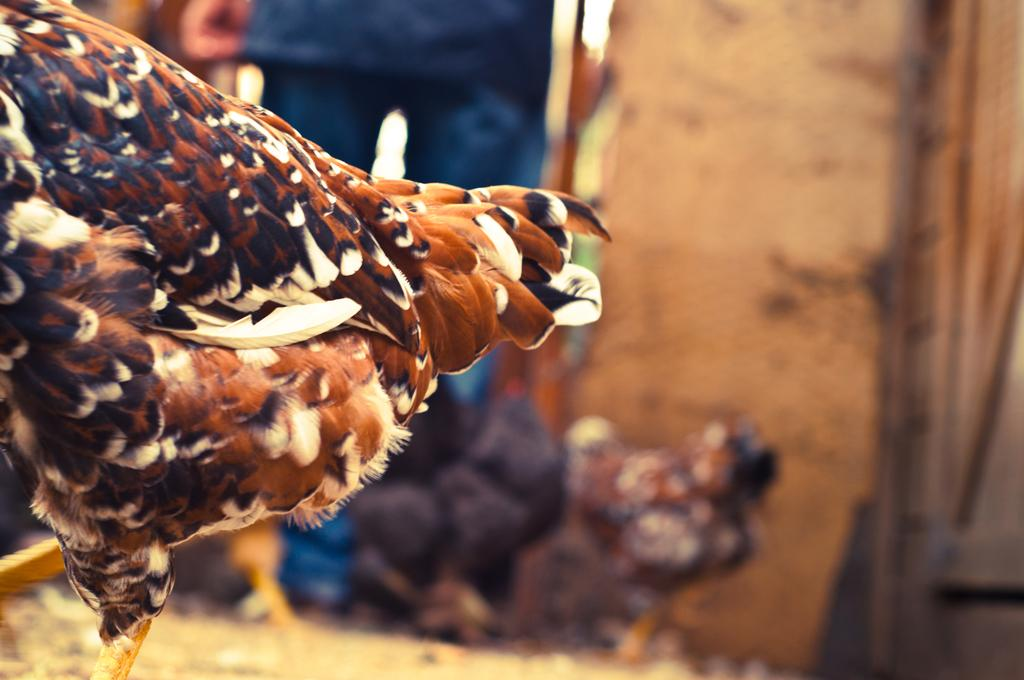What animals can be seen walking in the image? There are two hens walking in the image, one on the left side and another on the right side. Can you describe the position of the man in the image? The man is standing in the background of the image. What type of work is the guitar doing in the image? There is no guitar present in the image; it only features two hens walking and a man standing in the background. 